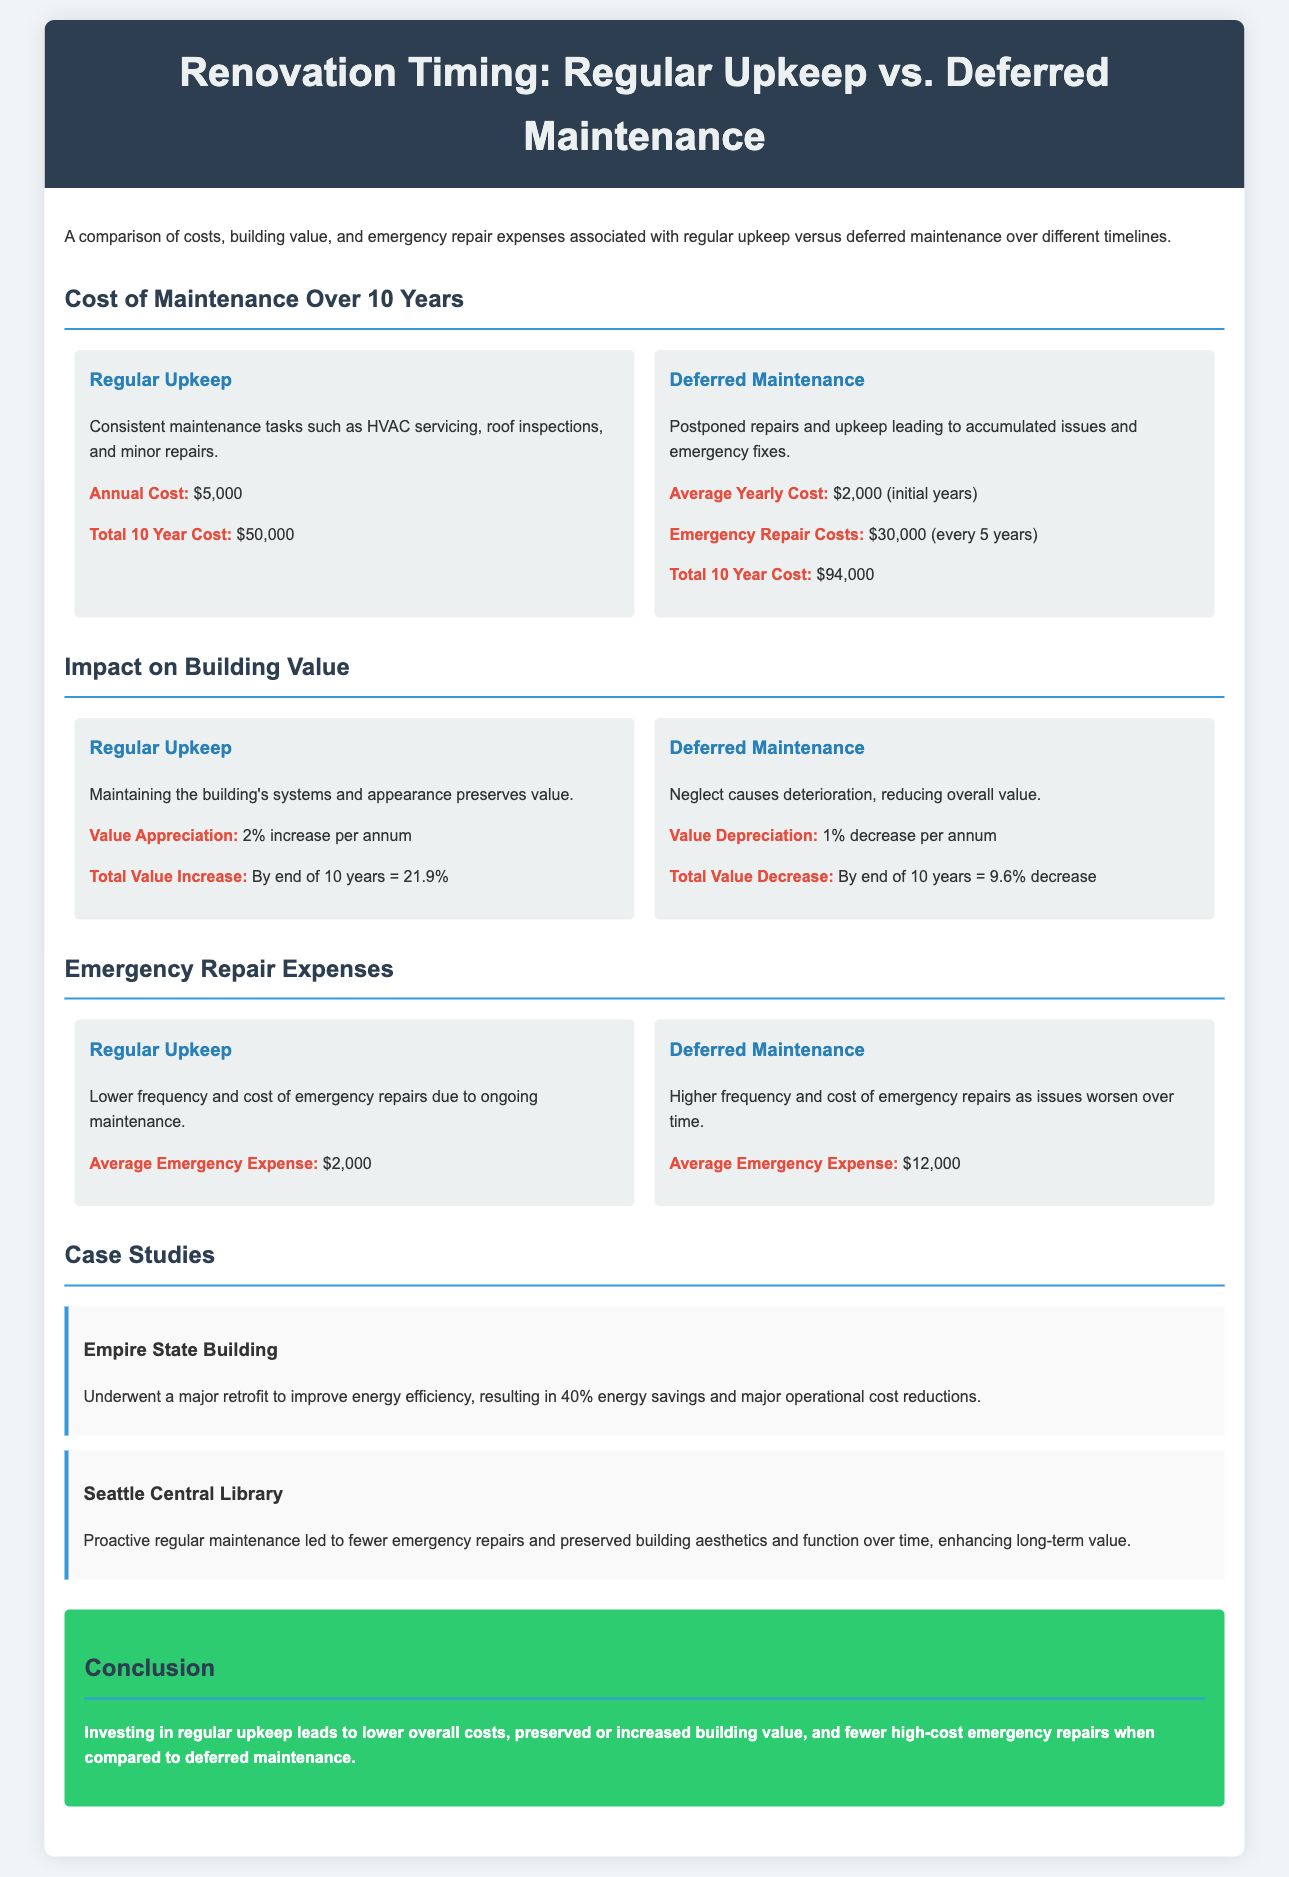What is the annual cost of regular upkeep? The document lists the annual cost of regular upkeep as $5,000.
Answer: $5,000 What is the total 10-year cost for deferred maintenance? The total cost for deferred maintenance over ten years is provided as $94,000.
Answer: $94,000 What is the value appreciation for regular upkeep per annum? The document states a value appreciation of 2% increase per annum for regular upkeep.
Answer: 2% What is the total value decrease for deferred maintenance over 10 years? The total value decrease for deferred maintenance after ten years is noted as 9.6%.
Answer: 9.6% What is the average emergency expense for regular upkeep? The average emergency expense related to regular upkeep is indicated as $2,000.
Answer: $2,000 How much does regular upkeep save in emergency repair costs? Regular upkeep leads to lower emergency repair expenses, averaging $2,000 compared to $12,000 for deferred maintenance, representing a savings of $10,000.
Answer: $10,000 How often do emergency repairs occur for deferred maintenance? The document does not specify a frequency, but it implies that higher frequency of repairs is required due to continued neglect.
Answer: Higher frequency What was one outcome of the Empire State Building's retrofit? The retrofit improved energy efficiency resulting in 40% energy savings.
Answer: 40% energy savings What conclusion does the document present regarding maintenance types? The conclusion emphasizes that investing in regular upkeep leads to lower overall costs and preserved building value compared to deferred maintenance.
Answer: Lower overall costs and preserved building value 